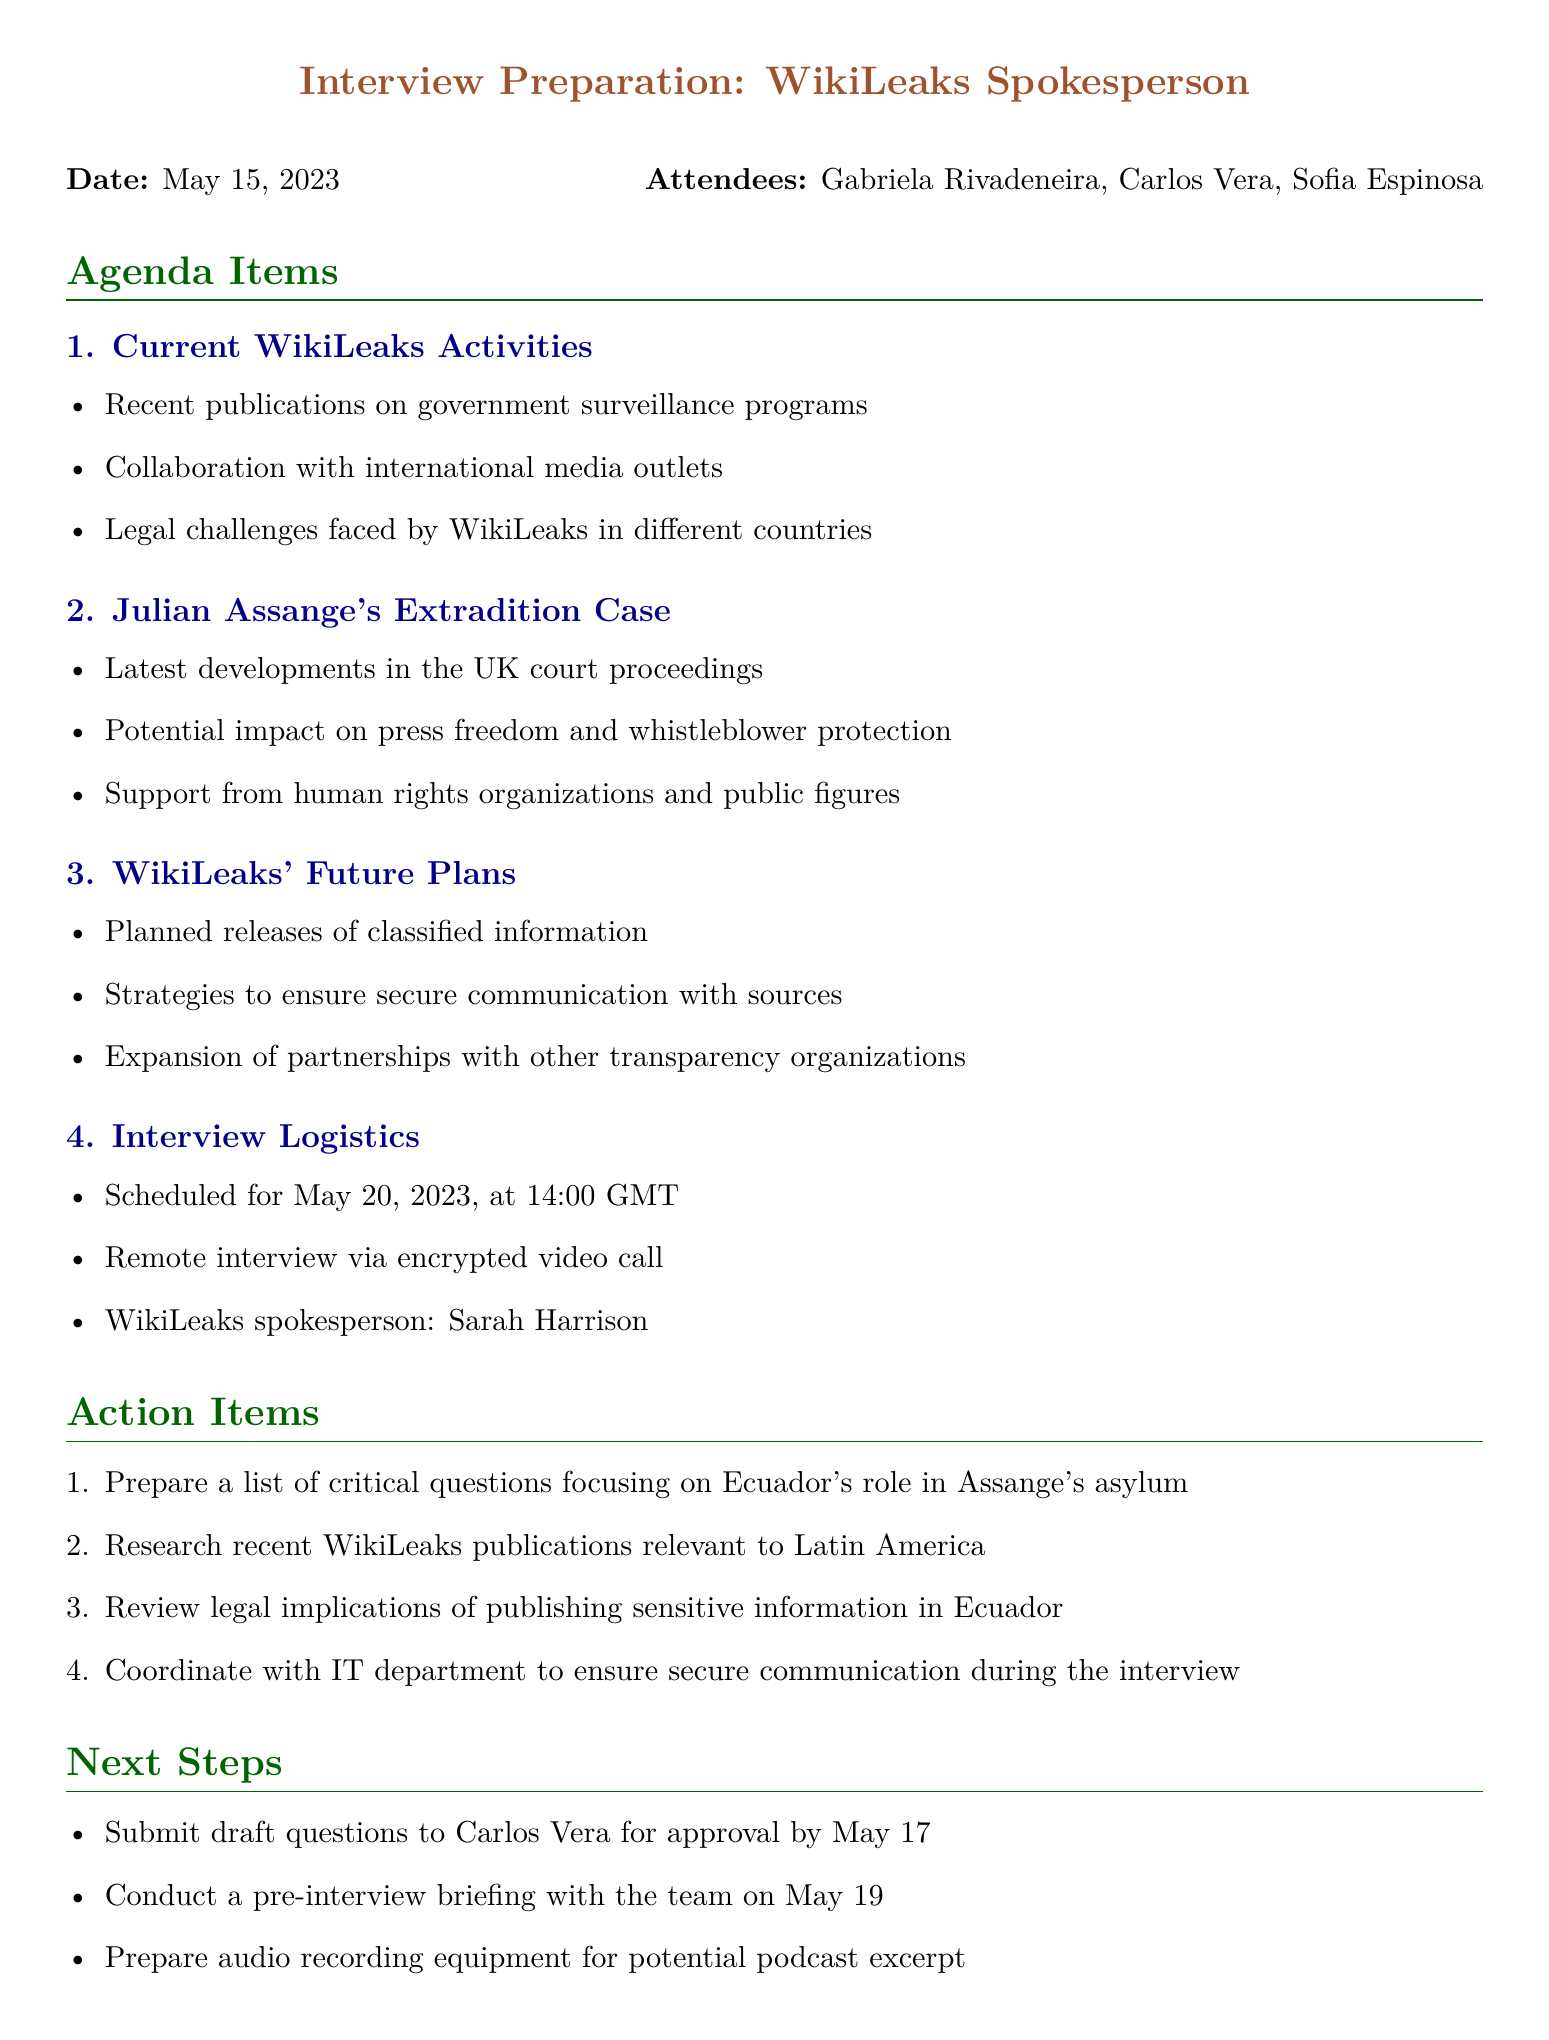What is the date of the meeting? The date of the meeting is provided in the document.
Answer: May 15, 2023 Who is the spokesperson for WikiLeaks in the upcoming interview? The document specifies who will be representing WikiLeaks for the interview.
Answer: Sarah Harrison When is the scheduled date and time for the interview? The document lists the scheduled time for the interview.
Answer: May 20, 2023, at 14:00 GMT What topic addresses legal challenges faced by WikiLeaks? One of the agenda items includes specific key points regarding legal challenges.
Answer: Current WikiLeaks Activities What is one of the action items mentioned for the interview preparation? The document contains a list of action items related to preparing for the interview.
Answer: Prepare a list of critical questions focusing on Ecuador's role in Assange's asylum What is one of WikiLeaks' future plans mentioned in the meeting? The future plans related to WikiLeaks are itemized in the agenda.
Answer: Planned releases of classified information Which attendees were present at the meeting? The document lists the names of attendees at the meeting.
Answer: Gabriela Rivadeneira, Carlos Vera, Sofia Espinosa When is the deadline for submitting draft questions for approval? The document specifies the deadline for submitting draft questions.
Answer: May 17 What type of interview format is planned for the WikiLeaks interview? The logistics section of the document outlines the format of the interview.
Answer: Encrypted video call 